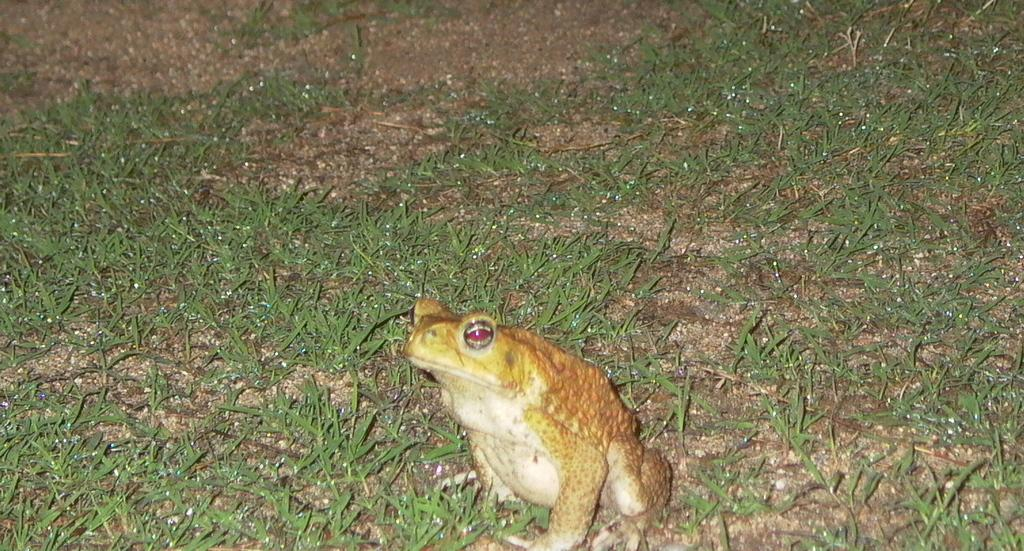What type of animal is present in the image? There is a frog in the image. What is the color of the grass in the image? The grass in the image is green. Where is the scarecrow located in the image? There is no scarecrow present in the image. What type of root can be seen growing from the frog in the image? There is no root growing from the frog in the image, as frogs are not plants and do not have roots. 